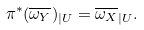Convert formula to latex. <formula><loc_0><loc_0><loc_500><loc_500>\pi ^ { * } ( \overline { \omega _ { Y } } ) _ { | U } = \overline { \omega _ { X } } _ { | U } .</formula> 